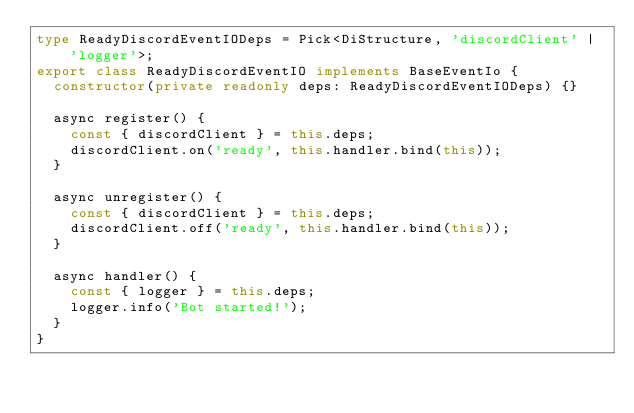Convert code to text. <code><loc_0><loc_0><loc_500><loc_500><_TypeScript_>type ReadyDiscordEventIODeps = Pick<DiStructure, 'discordClient' | 'logger'>;
export class ReadyDiscordEventIO implements BaseEventIo {
  constructor(private readonly deps: ReadyDiscordEventIODeps) {}

  async register() {
    const { discordClient } = this.deps;
    discordClient.on('ready', this.handler.bind(this));
  }

  async unregister() {
    const { discordClient } = this.deps;
    discordClient.off('ready', this.handler.bind(this));
  }

  async handler() {
    const { logger } = this.deps;
    logger.info('Bot started!');
  }
}
</code> 